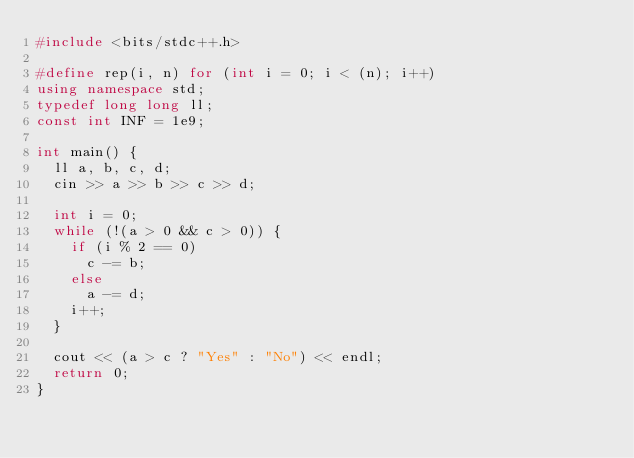<code> <loc_0><loc_0><loc_500><loc_500><_C++_>#include <bits/stdc++.h>

#define rep(i, n) for (int i = 0; i < (n); i++)
using namespace std;
typedef long long ll;
const int INF = 1e9;

int main() {
  ll a, b, c, d;
  cin >> a >> b >> c >> d;

  int i = 0;
  while (!(a > 0 && c > 0)) {
    if (i % 2 == 0)
      c -= b;
    else
      a -= d;
    i++;
  }

  cout << (a > c ? "Yes" : "No") << endl;
  return 0;
}
</code> 